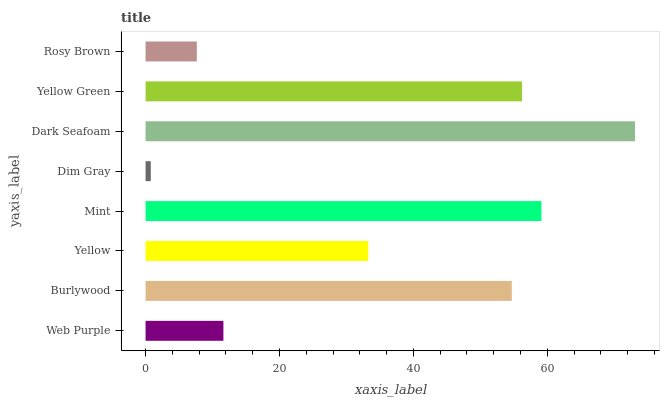Is Dim Gray the minimum?
Answer yes or no. Yes. Is Dark Seafoam the maximum?
Answer yes or no. Yes. Is Burlywood the minimum?
Answer yes or no. No. Is Burlywood the maximum?
Answer yes or no. No. Is Burlywood greater than Web Purple?
Answer yes or no. Yes. Is Web Purple less than Burlywood?
Answer yes or no. Yes. Is Web Purple greater than Burlywood?
Answer yes or no. No. Is Burlywood less than Web Purple?
Answer yes or no. No. Is Burlywood the high median?
Answer yes or no. Yes. Is Yellow the low median?
Answer yes or no. Yes. Is Mint the high median?
Answer yes or no. No. Is Dim Gray the low median?
Answer yes or no. No. 